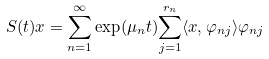Convert formula to latex. <formula><loc_0><loc_0><loc_500><loc_500>S ( t ) x = \underset { n = 1 } { \overset { \infty } { \sum } } \exp ( \mu _ { n } t ) \overset { r _ { n } } { \underset { j = 1 } { \sum } } \langle x , \varphi _ { n j } \rangle \varphi _ { n j }</formula> 